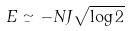<formula> <loc_0><loc_0><loc_500><loc_500>E \simeq - N J \sqrt { \log 2 }</formula> 